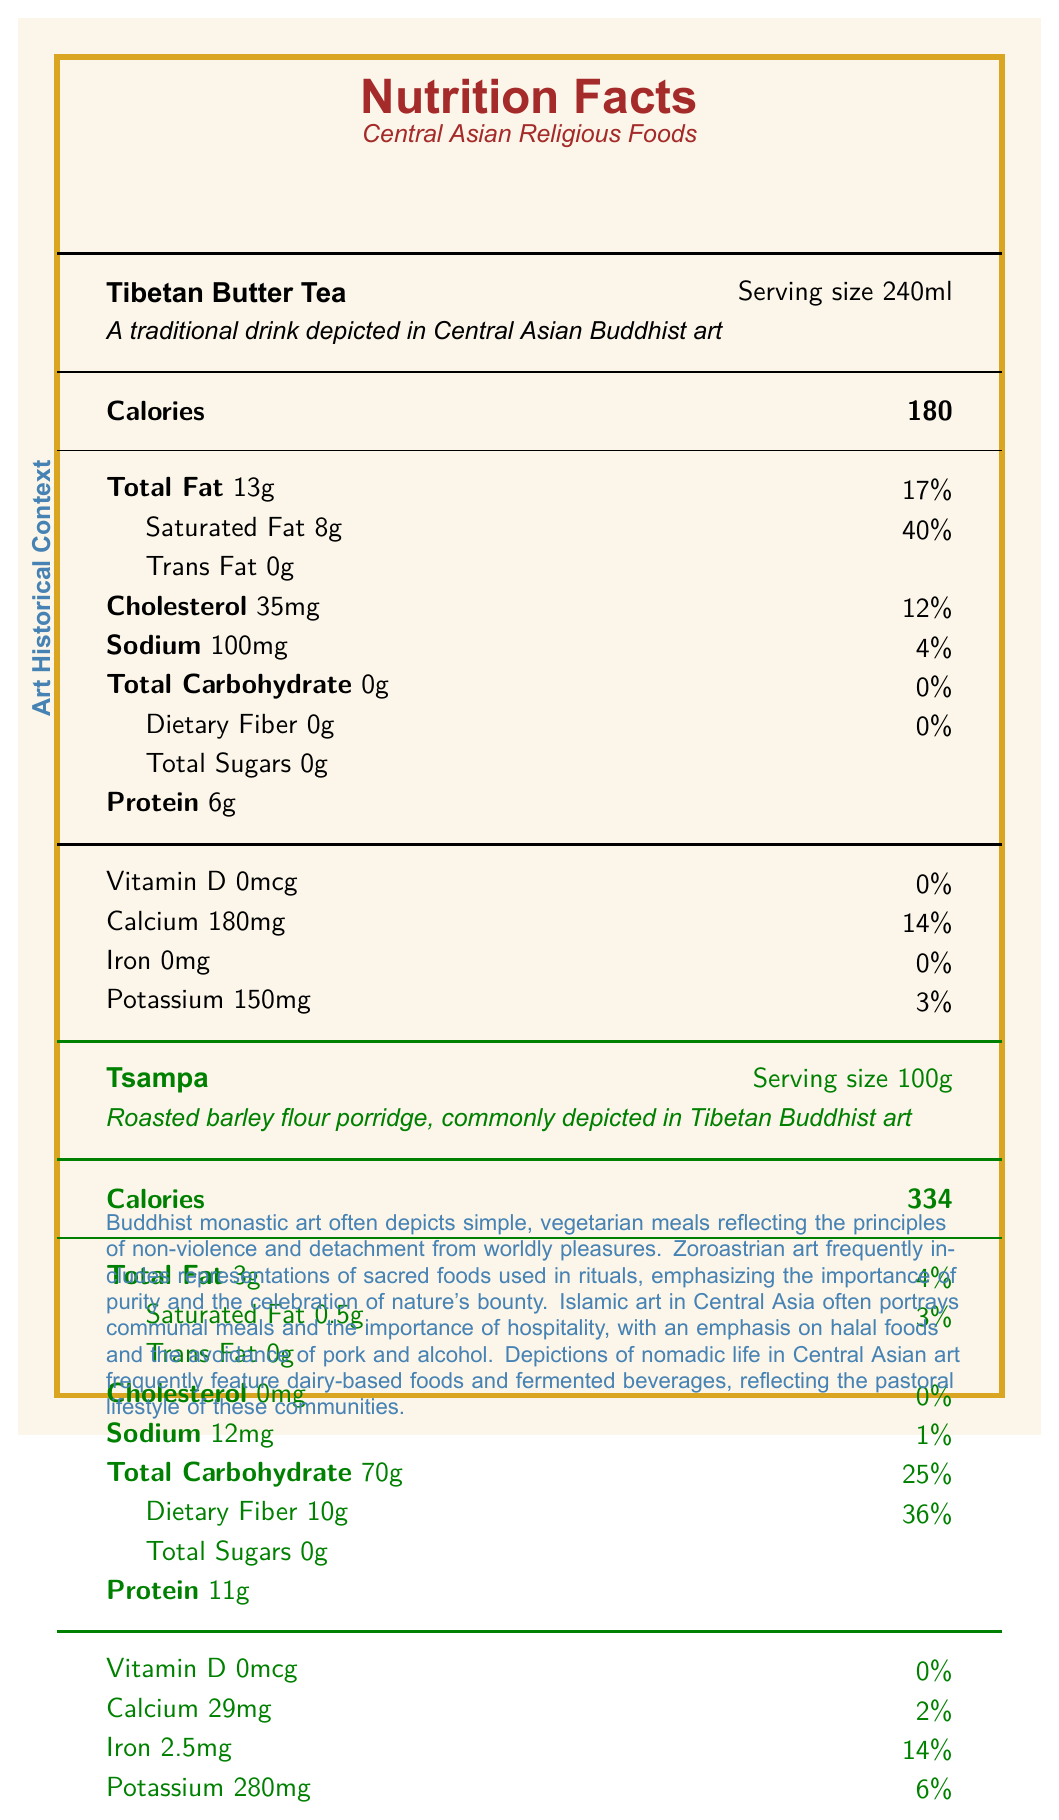what is the serving size of Tibetan Butter Tea? The document states that the serving size of Tibetan Butter Tea is 240ml.
Answer: 240ml how much protein does Tsampa contain per serving? According to the document, Tsampa contains 11g of protein per 100g serving.
Answer: 11g what is the main carbohydrate content in Sumalak? The document indicates that Sumalak has 25g of total carbohydrate per 50g serving.
Answer: 25g which food item has the highest sodium content? The document shows that Naan Bread has 570mg of sodium per 100g serving, which is the highest among the listed items.
Answer: Naan Bread Is there any cholesterol in Kumis? The document states that Kumis contains 10mg of cholesterol per 200ml serving.
Answer: Yes what is the artistic significance of dairy products in nomadic traditions? The document under the "nutritional significance" section explains the role of dairy products in nomadic traditions depicted in Central Asian art.
Answer: Dairy products are frequently depicted in nomadic art to highlight their importance as a source of calcium and vitamin D in pastoral diets. which of these foods has the highest iron content? A. Butter Tea B. Tsampa C. Sumalak D. Kumis The document shows that Tsampa has 2.5mg of iron, which is the highest among the provided options.
Answer: B. Tsampa which nutrient is almost absent in all the listed foods? A. Vitamin D B. Calcium C. Iron D. Potassium The document indicates that Vitamin D is either absent or present in very low quantities in all the listed foods.
Answer: A. Vitamin D Do any of the foods contain trans fat? The document indicates that none of the foods listed contain trans fat (0g trans fat).
Answer: No summarize the nutritional importance of fermented foods as depicted in the document. The document under "nutritional significance" mentions that these fermented foods offer probiotics and improved nutrient absorption.
Answer: Fermented foods like kumis and sumalak, as depicted in Central Asian art, provide important probiotics and enhanced nutrient bioavailability. what is the specific vitamin discussed in relation to dairy products? The document highlights that dairy products are an important source of Vitamin D.
Answer: Vitamin D are there any foods with added sugars? The document does not show any added sugars for the foods listed; all sugars are naturally occurring.
Answer: No What specific historical aspects are emphasized for foods depicted in Islamic Central Asian art? According to the document under "art historical context," Islamic Central Asian art emphasizes communal meals, hospitality, adherence to halal foods, and avoidance of pork and alcohol.
Answer: Communal meals, hospitality, halal foods, and avoidance of pork and alcohol. which food has the highest protein content per serving? A. Tibetan Butter Tea B. Tsampa C. Sumalak D. Kumis The document indicates that Tsampa has 11g of protein per 100g serving, which is the highest compared to other foods.
Answer: B. Tsampa Is the potassium content higher in Kumis or Tibetan Butter Tea? The document states that Kumis has 180mg of potassium per 200ml serving, compared to Tibetan Butter Tea, which has 150mg.
Answer: Kumis describe the general purpose of this document. The document details the nutritional content of different traditional foods from Central Asian art, citing their historical significance and nutritional values.
Answer: The document provides a comparative nutrition profile of various foods depicted in Central Asian religious art and discusses their historical and cultural significance. how often is saturated fat found in these foods? The document shows that most foods listed contain saturated fat, with Tibetan Butter Tea and Kumis having notable amounts.
Answer: Frequently which food item has the least amount of total fat? The document indicates that Sumalak has only 0.5g of total fat per 50g serving, which is the least among the listed items.
Answer: Sumalak what type of meals are often depicted in Buddhist monastic art? The document mentions that Buddhist monastic art often includes simple, vegetarian meals reflecting principles of non-violence and detachment from worldly pleasures.
Answer: Simple, vegetarian meals what historical context does the document provide about the representation of Tsampa in art? The document describes Tsampa as a roasted barley flour porridge commonly depicted in Tibetan Buddhist art.
Answer: Depicted in Tibetan Buddhist art what is the vitamin D percentage in Sumalak? The document does not provide a specific percentage for the Vitamin D content in Sumalak.
Answer: Cannot be determined 